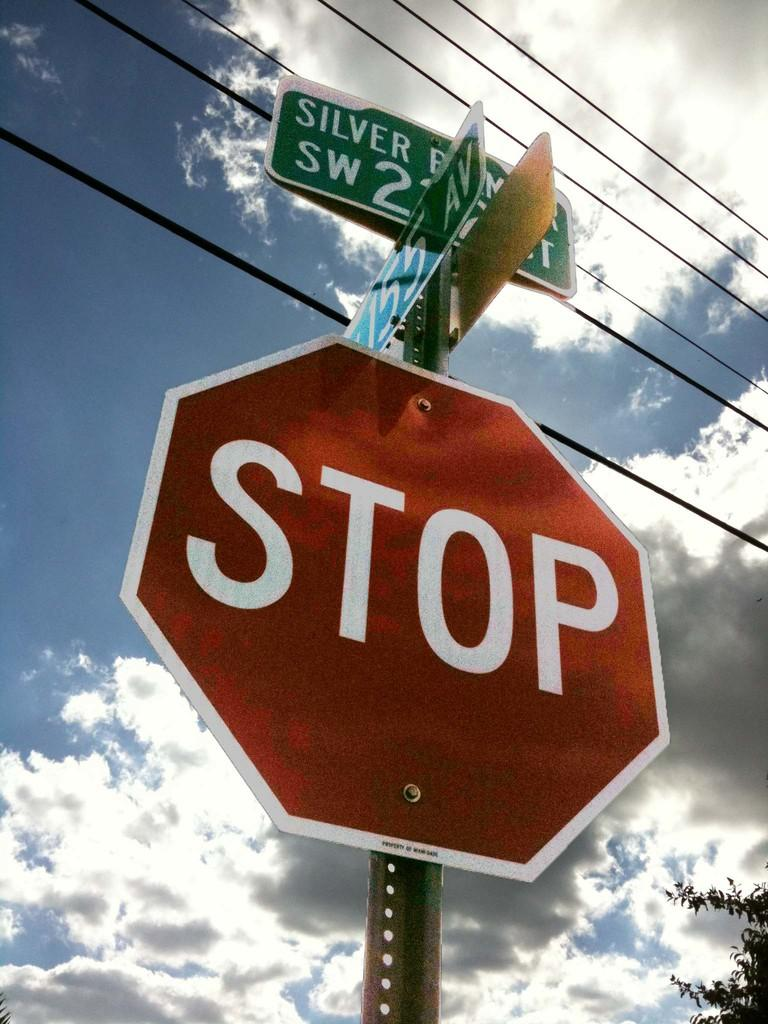Provide a one-sentence caption for the provided image. A hexagonal red stop sign is seen from below underneath a silver lined clouded sky. 